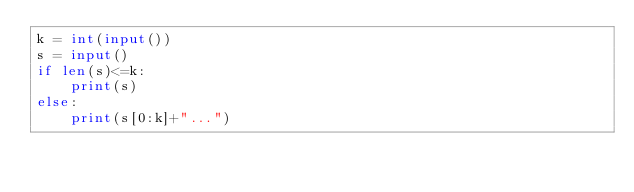<code> <loc_0><loc_0><loc_500><loc_500><_Python_>k = int(input())
s = input()
if len(s)<=k:
    print(s)
else:
    print(s[0:k]+"...")</code> 